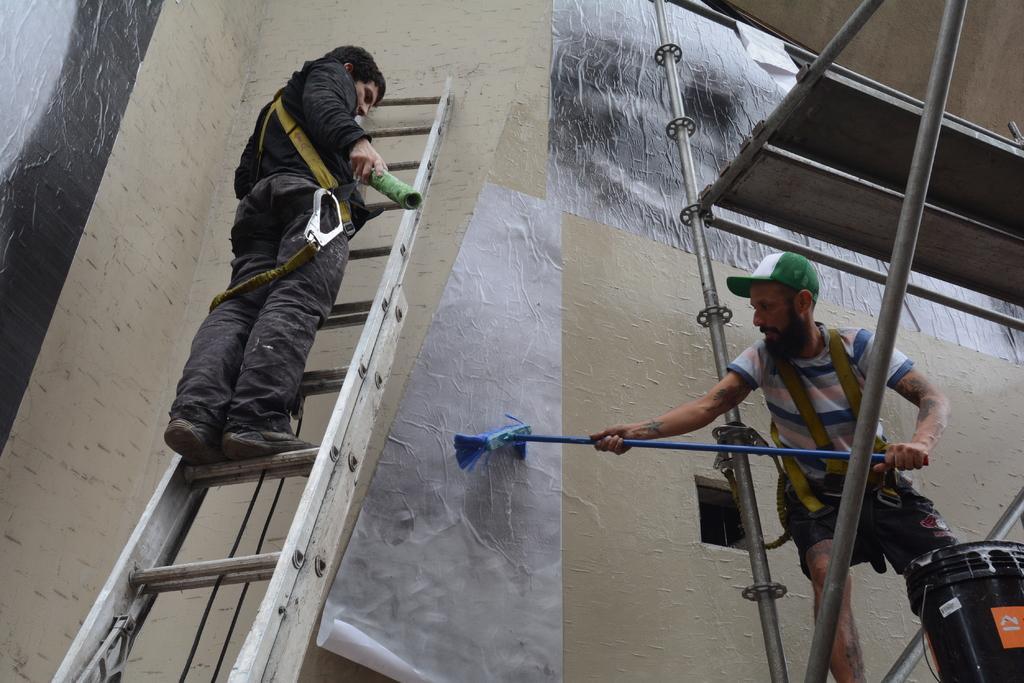Could you give a brief overview of what you see in this image? This image consists of two men painting a building. On the left, the man is standing on the ladder. On the right, the man is brushing the wall. He is wearing a green cap. At the bottom right, we can see a bucket in black color. 